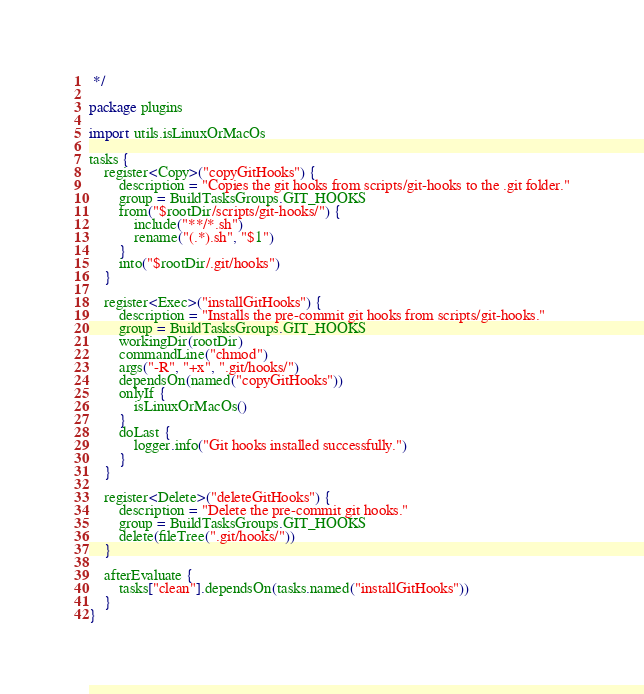<code> <loc_0><loc_0><loc_500><loc_500><_Kotlin_> */

package plugins

import utils.isLinuxOrMacOs

tasks {
    register<Copy>("copyGitHooks") {
        description = "Copies the git hooks from scripts/git-hooks to the .git folder."
        group = BuildTasksGroups.GIT_HOOKS
        from("$rootDir/scripts/git-hooks/") {
            include("**/*.sh")
            rename("(.*).sh", "$1")
        }
        into("$rootDir/.git/hooks")
    }

    register<Exec>("installGitHooks") {
        description = "Installs the pre-commit git hooks from scripts/git-hooks."
        group = BuildTasksGroups.GIT_HOOKS
        workingDir(rootDir)
        commandLine("chmod")
        args("-R", "+x", ".git/hooks/")
        dependsOn(named("copyGitHooks"))
        onlyIf {
            isLinuxOrMacOs()
        }
        doLast {
            logger.info("Git hooks installed successfully.")
        }
    }

    register<Delete>("deleteGitHooks") {
        description = "Delete the pre-commit git hooks."
        group = BuildTasksGroups.GIT_HOOKS
        delete(fileTree(".git/hooks/"))
    }

    afterEvaluate {
        tasks["clean"].dependsOn(tasks.named("installGitHooks"))
    }
}
</code> 